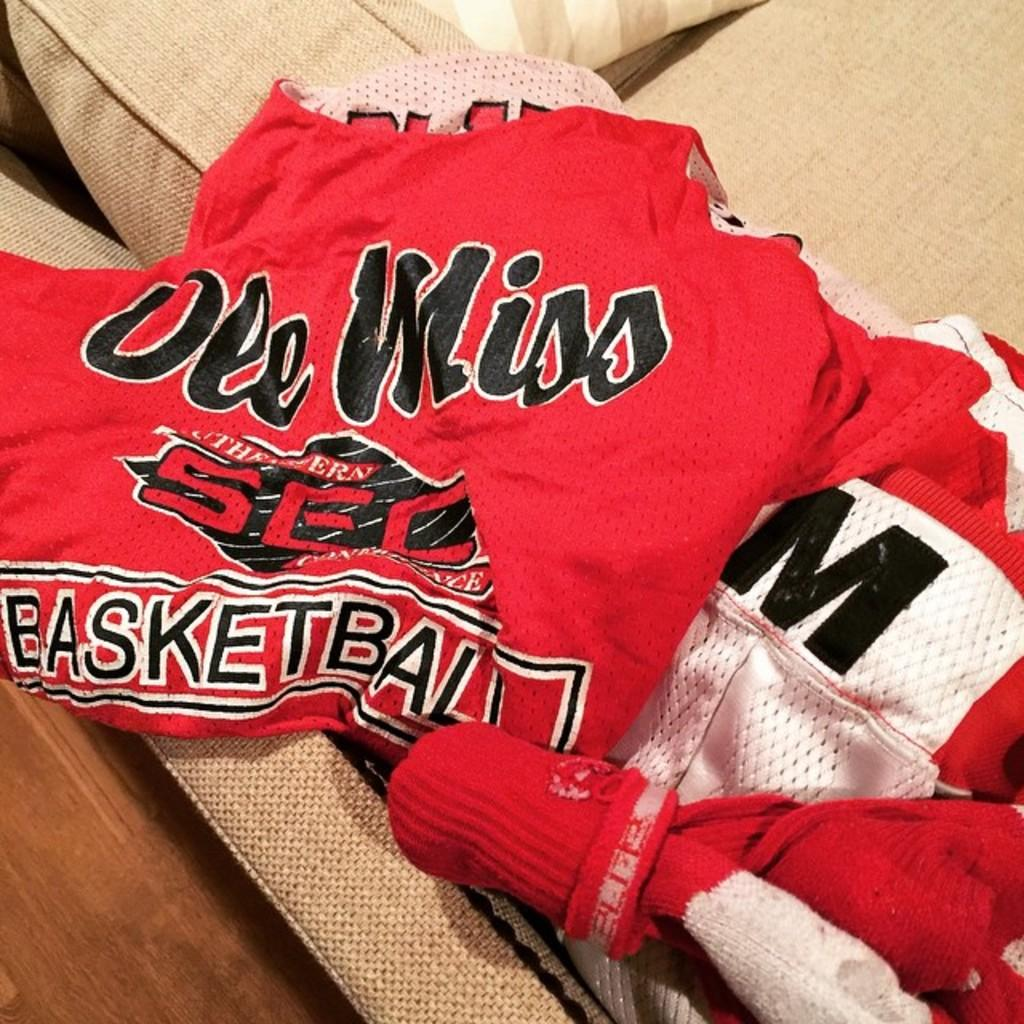<image>
Give a short and clear explanation of the subsequent image. a red piece of clothing with ole miss on it 